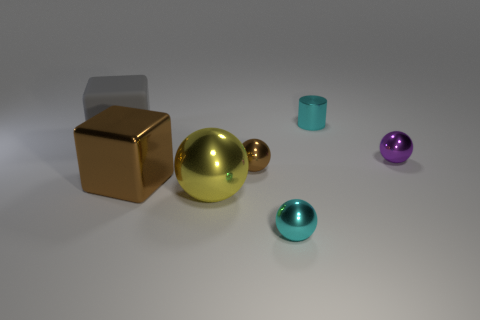Do the purple metallic ball and the cylinder have the same size?
Your answer should be very brief. Yes. How many objects are either red metal cylinders or cyan metallic things behind the tiny purple metal ball?
Your answer should be compact. 1. There is a brown sphere that is the same size as the purple shiny object; what material is it?
Your answer should be very brief. Metal. There is a tiny thing that is behind the small brown metallic thing and in front of the gray rubber object; what material is it made of?
Offer a very short reply. Metal. There is a cyan thing behind the tiny cyan ball; is there a gray rubber thing that is on the right side of it?
Offer a very short reply. No. How big is the object that is behind the purple ball and on the right side of the gray matte cube?
Provide a short and direct response. Small. What number of blue things are either matte cylinders or matte objects?
Provide a succinct answer. 0. There is a metal thing that is the same size as the yellow sphere; what is its shape?
Make the answer very short. Cube. How many other objects are the same color as the tiny cylinder?
Offer a very short reply. 1. How big is the cyan object that is behind the tiny cyan thing in front of the gray rubber thing?
Your answer should be very brief. Small. 